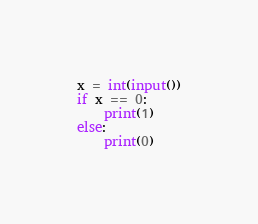Convert code to text. <code><loc_0><loc_0><loc_500><loc_500><_Python_>x = int(input())
if x == 0:
    print(1)
else:
    print(0)</code> 